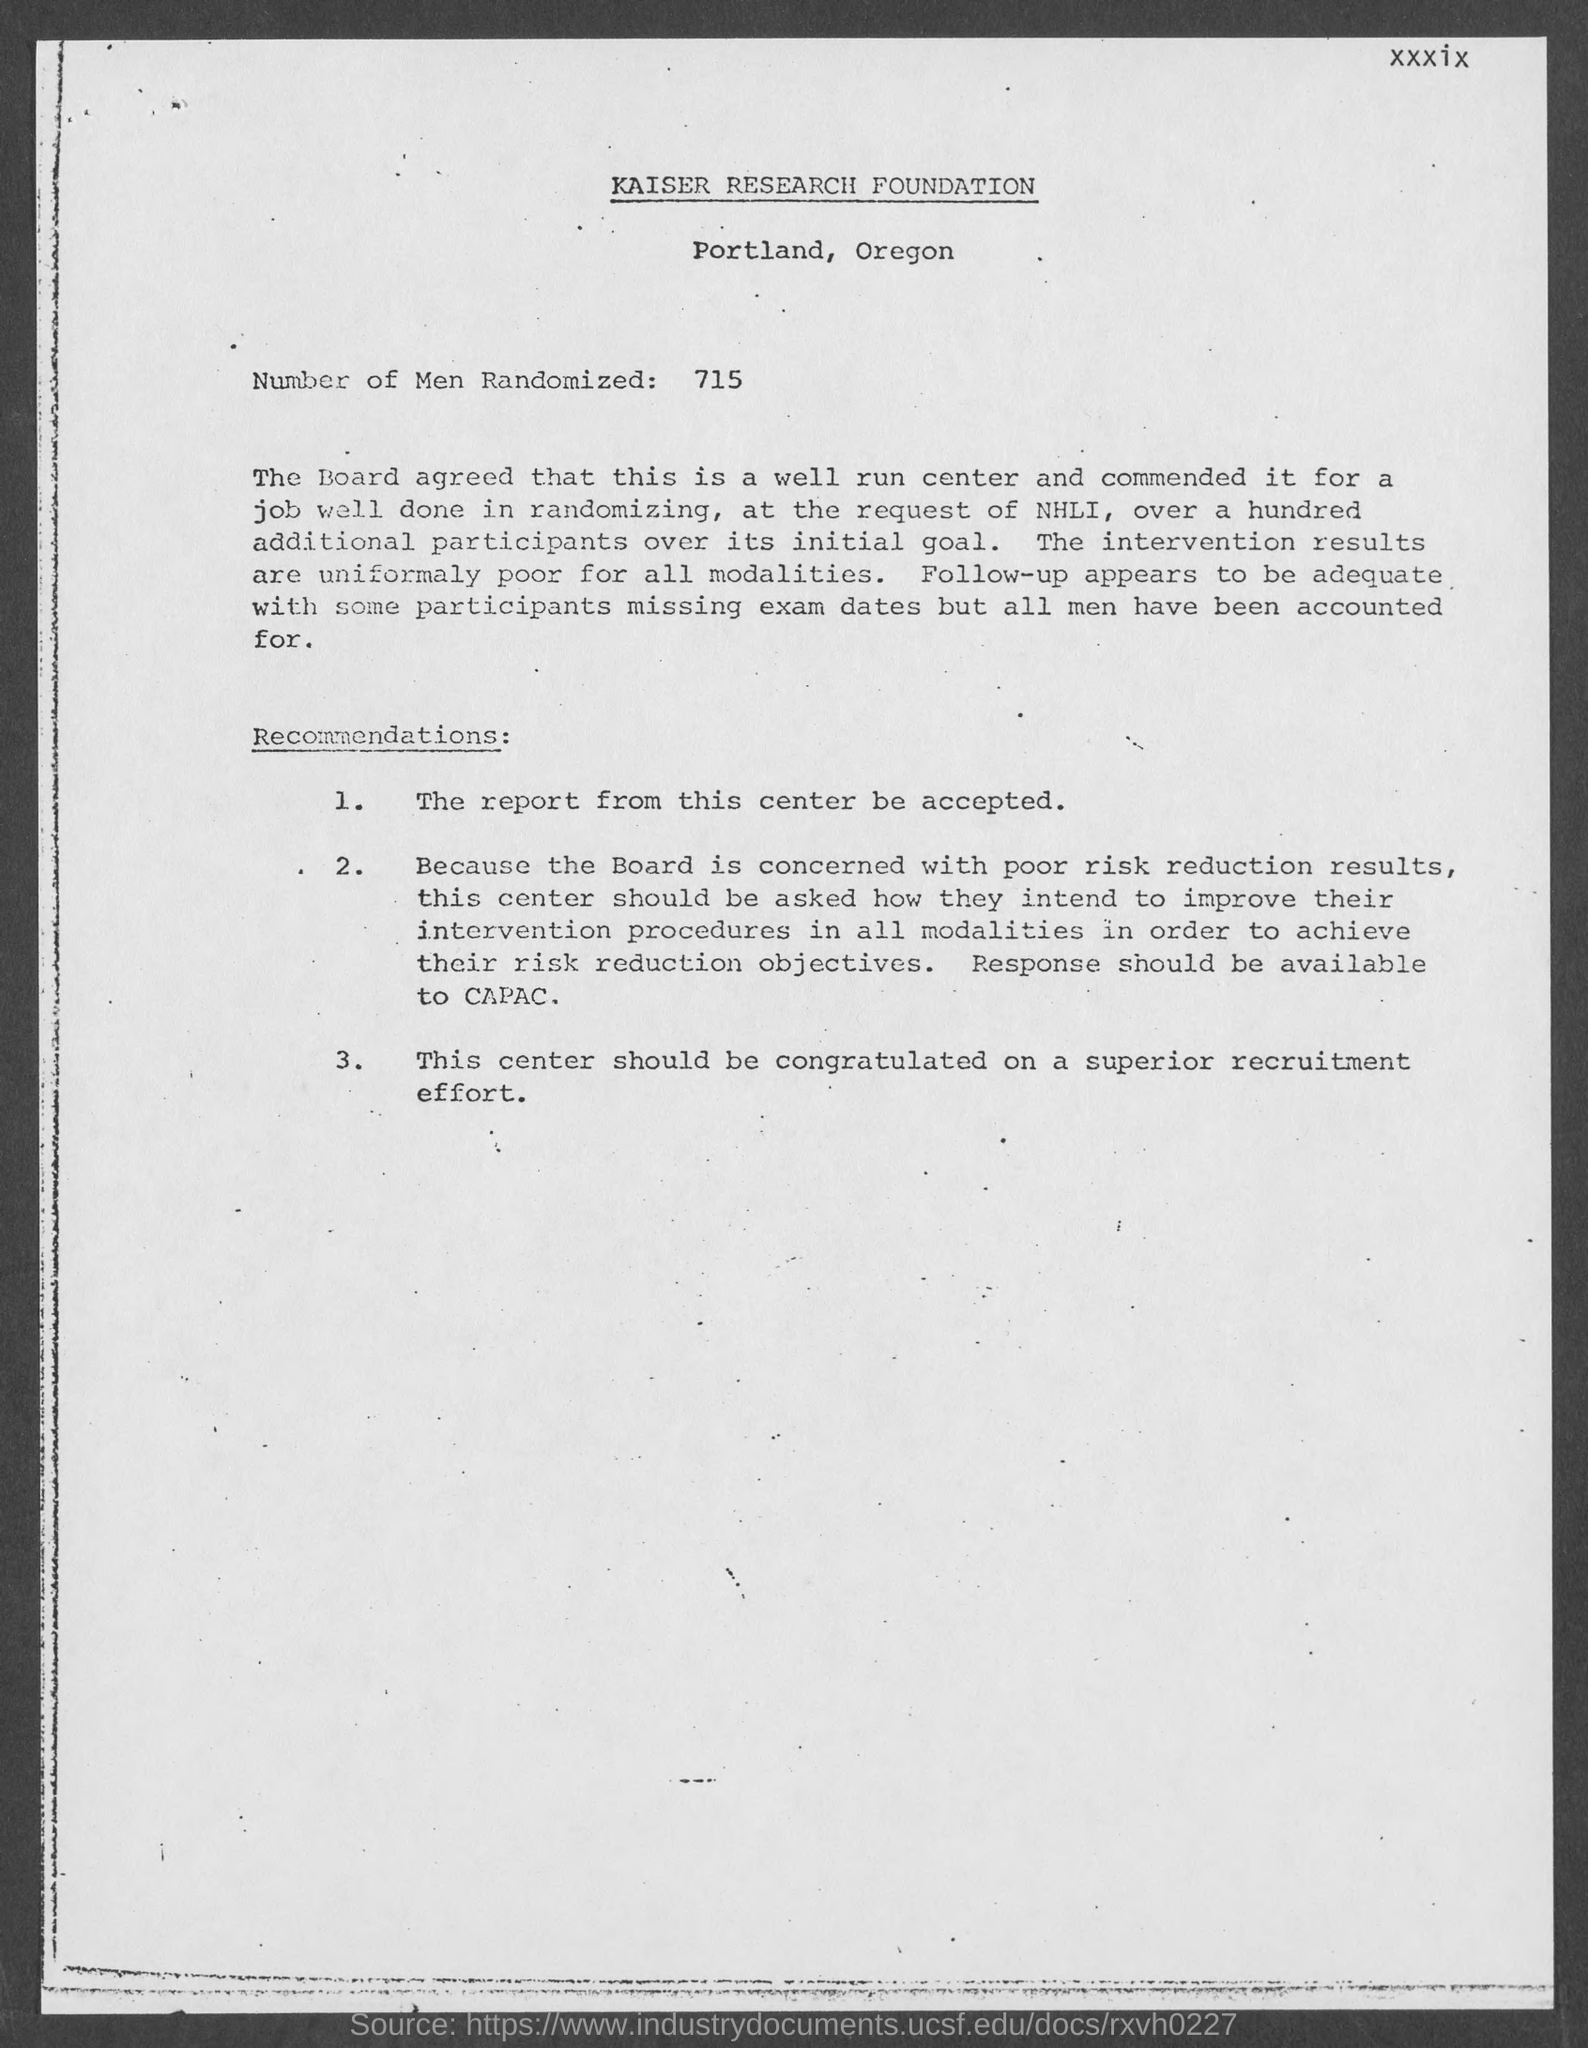List a handful of essential elements in this visual. 715 individuals were randomly selected for this study. 